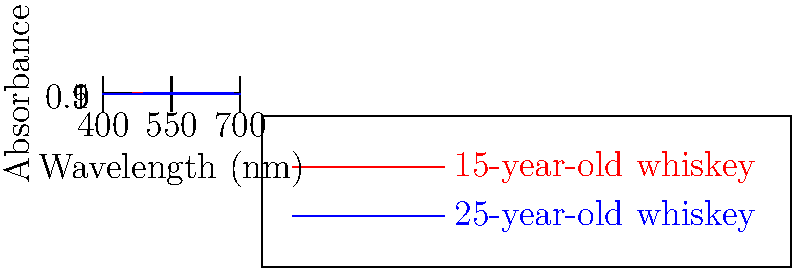As a professional chef specializing in Irish cuisine, you're asked to analyze the color spectrum of two Irish whiskeys to estimate their alcohol content. The graph shows the absorbance spectra of a 15-year-old and a 25-year-old Irish whiskey. Based on the spectral differences and your knowledge of whiskey aging, which whiskey is likely to have a higher alcohol content, and why? To answer this question, we need to consider several factors:

1. Aging process: As whiskey ages, it interacts with the wood of the barrel, extracting compounds that affect both color and flavor.

2. Evaporation: During aging, some alcohol evaporates (known as the "angel's share"), typically increasing the concentration of other compounds relative to alcohol.

3. Spectral analysis:
   - The 25-year-old whiskey (blue line) shows higher absorbance overall, indicating a darker color.
   - It has a more pronounced peak around 550 nm, which is in the yellow-green region of the visible spectrum.

4. Color and alcohol content relationship:
   - Darker color usually indicates more wood extraction and potentially lower alcohol content due to longer evaporation time.
   - However, some distilleries may adjust alcohol content before bottling.

5. Irish whiskey regulations:
   - Irish whiskey must be bottled at a minimum of 40% ABV (alcohol by volume).
   - Cask strength whiskeys can have higher alcohol content, but are less common.

Considering these factors, the 15-year-old whiskey is likely to have a higher alcohol content because:
   - It has had less time for alcohol to evaporate during aging.
   - Its lighter color suggests less wood interaction and potentially less dilution from extracted compounds.
   - Irish distilleries often bottle younger whiskeys at higher proof to preserve bold flavors.
Answer: 15-year-old whiskey 